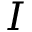Convert formula to latex. <formula><loc_0><loc_0><loc_500><loc_500>I</formula> 